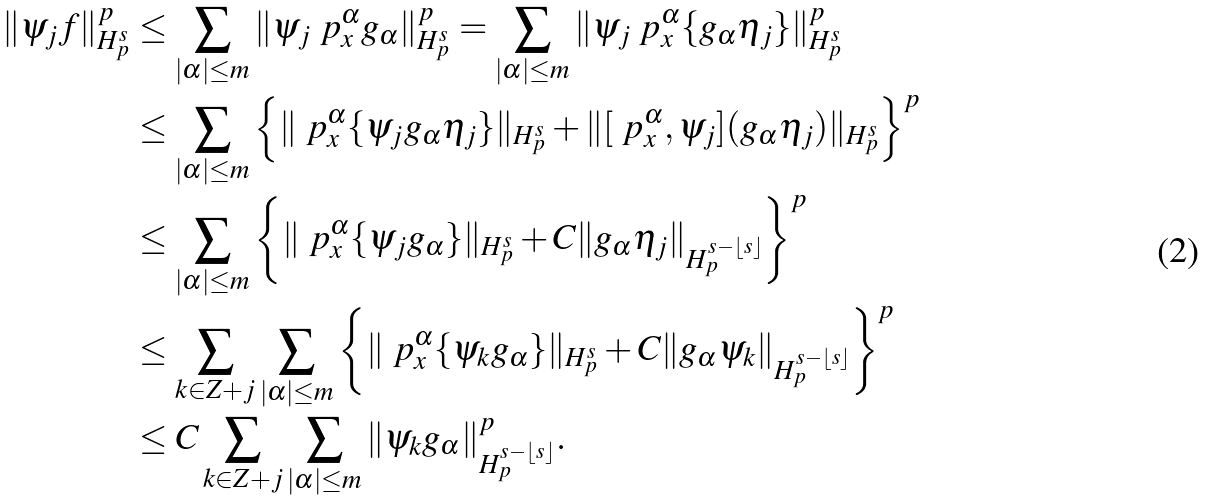<formula> <loc_0><loc_0><loc_500><loc_500>\| \psi _ { j } f \| ^ { p } _ { H ^ { s } _ { p } } & \leq \sum _ { | \alpha | \leq m } \| \psi _ { j } \ p ^ { \alpha } _ { x } g _ { \alpha } \| ^ { p } _ { H ^ { s } _ { p } } = \sum _ { | \alpha | \leq m } \| \psi _ { j } \ p ^ { \alpha } _ { x } \{ g _ { \alpha } \eta _ { j } \} \| ^ { p } _ { H ^ { s } _ { p } } \\ & \leq \sum _ { | \alpha | \leq m } \left \{ \| \ p ^ { \alpha } _ { x } \{ \psi _ { j } g _ { \alpha } \eta _ { j } \} \| _ { H ^ { s } _ { p } } + \| [ \ p ^ { \alpha } _ { x } , \psi _ { j } ] ( g _ { \alpha } \eta _ { j } ) \| _ { H ^ { s } _ { p } } \right \} ^ { p } \\ & \leq \sum _ { | \alpha | \leq m } \left \{ \| \ p ^ { \alpha } _ { x } \{ \psi _ { j } g _ { \alpha } \} \| _ { H ^ { s } _ { p } } + C \| g _ { \alpha } \eta _ { j } \| _ { H ^ { s - \lfloor s \rfloor } _ { p } } \right \} ^ { p } \\ & \leq \sum _ { k \in Z + j } \sum _ { | \alpha | \leq m } \left \{ \| \ p ^ { \alpha } _ { x } \{ \psi _ { k } g _ { \alpha } \} \| _ { H ^ { s } _ { p } } + C \| g _ { \alpha } \psi _ { k } \| _ { H ^ { s - \lfloor s \rfloor } _ { p } } \right \} ^ { p } \\ & \leq C \sum _ { k \in Z + j } \sum _ { | \alpha | \leq m } \| \psi _ { k } g _ { \alpha } \| _ { H ^ { s - \lfloor s \rfloor } _ { p } } ^ { p } .</formula> 